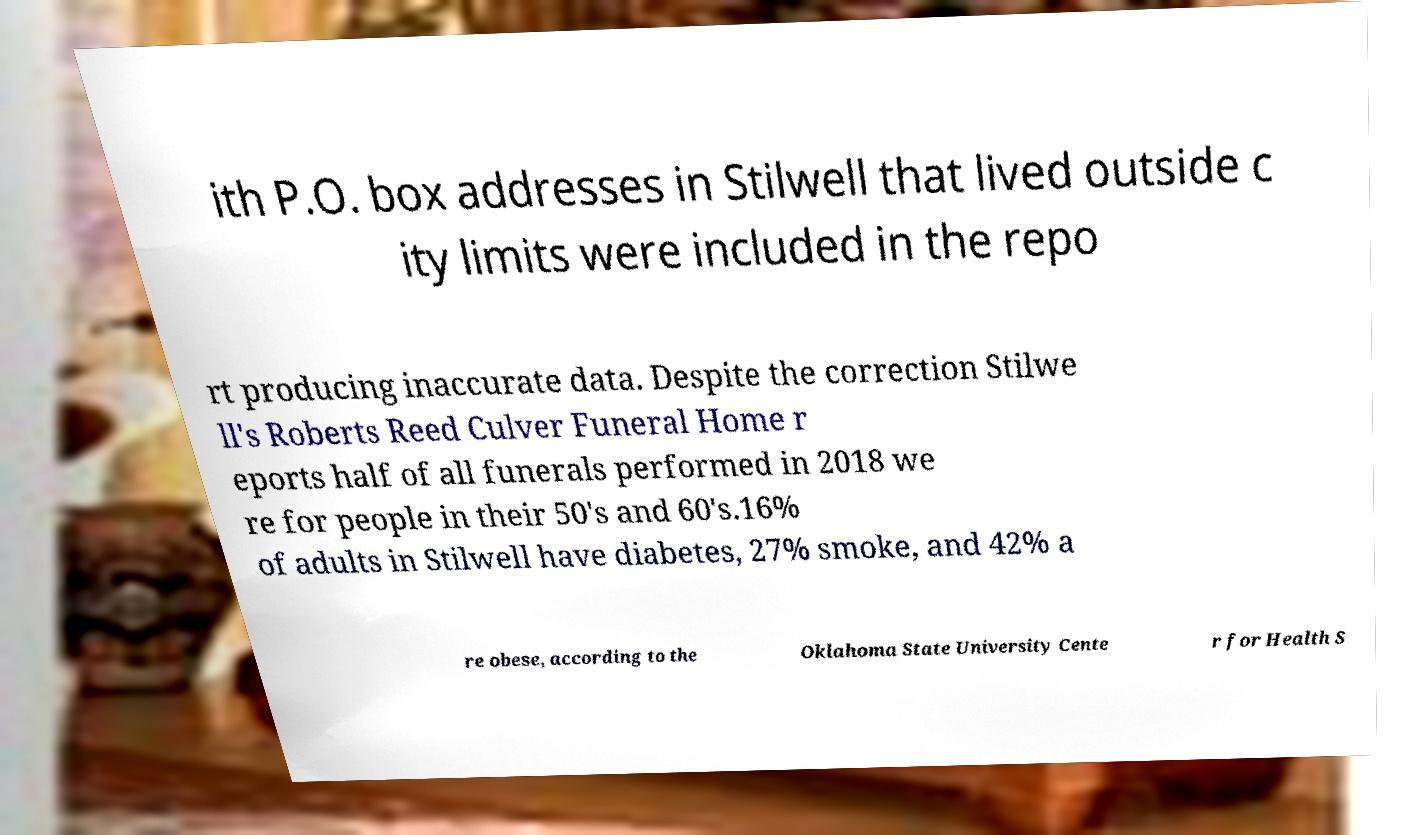I need the written content from this picture converted into text. Can you do that? ith P.O. box addresses in Stilwell that lived outside c ity limits were included in the repo rt producing inaccurate data. Despite the correction Stilwe ll's Roberts Reed Culver Funeral Home r eports half of all funerals performed in 2018 we re for people in their 50's and 60's.16% of adults in Stilwell have diabetes, 27% smoke, and 42% a re obese, according to the Oklahoma State University Cente r for Health S 